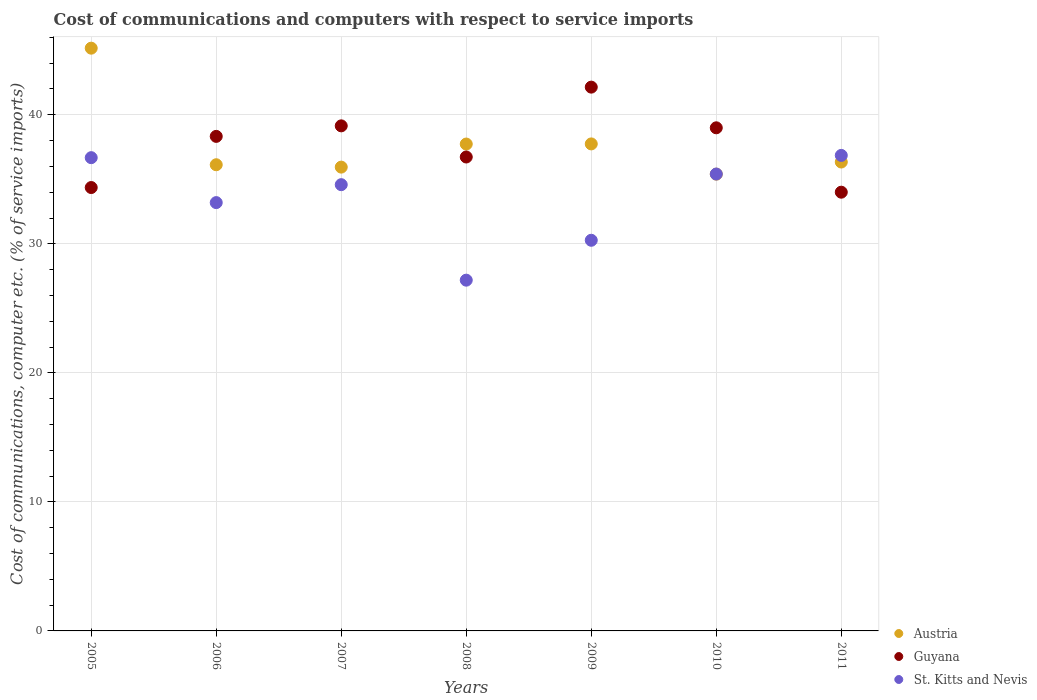How many different coloured dotlines are there?
Keep it short and to the point. 3. Is the number of dotlines equal to the number of legend labels?
Offer a terse response. Yes. What is the cost of communications and computers in Guyana in 2011?
Your response must be concise. 34. Across all years, what is the maximum cost of communications and computers in St. Kitts and Nevis?
Your answer should be very brief. 36.85. Across all years, what is the minimum cost of communications and computers in Austria?
Ensure brevity in your answer.  35.4. In which year was the cost of communications and computers in St. Kitts and Nevis maximum?
Provide a short and direct response. 2011. What is the total cost of communications and computers in St. Kitts and Nevis in the graph?
Ensure brevity in your answer.  234.17. What is the difference between the cost of communications and computers in St. Kitts and Nevis in 2008 and that in 2010?
Your response must be concise. -8.23. What is the difference between the cost of communications and computers in Guyana in 2009 and the cost of communications and computers in St. Kitts and Nevis in 2008?
Offer a very short reply. 14.96. What is the average cost of communications and computers in Austria per year?
Offer a terse response. 37.78. In the year 2008, what is the difference between the cost of communications and computers in Austria and cost of communications and computers in St. Kitts and Nevis?
Ensure brevity in your answer.  10.55. What is the ratio of the cost of communications and computers in Austria in 2009 to that in 2011?
Give a very brief answer. 1.04. Is the cost of communications and computers in Austria in 2008 less than that in 2011?
Offer a very short reply. No. Is the difference between the cost of communications and computers in Austria in 2006 and 2011 greater than the difference between the cost of communications and computers in St. Kitts and Nevis in 2006 and 2011?
Your answer should be compact. Yes. What is the difference between the highest and the second highest cost of communications and computers in Austria?
Offer a terse response. 7.42. What is the difference between the highest and the lowest cost of communications and computers in Guyana?
Ensure brevity in your answer.  8.14. Is the sum of the cost of communications and computers in Guyana in 2007 and 2009 greater than the maximum cost of communications and computers in Austria across all years?
Keep it short and to the point. Yes. Does the cost of communications and computers in Austria monotonically increase over the years?
Offer a very short reply. No. Is the cost of communications and computers in Austria strictly greater than the cost of communications and computers in Guyana over the years?
Keep it short and to the point. No. How many dotlines are there?
Your answer should be compact. 3. What is the difference between two consecutive major ticks on the Y-axis?
Make the answer very short. 10. Does the graph contain any zero values?
Your answer should be very brief. No. How many legend labels are there?
Offer a terse response. 3. What is the title of the graph?
Your response must be concise. Cost of communications and computers with respect to service imports. Does "Ghana" appear as one of the legend labels in the graph?
Keep it short and to the point. No. What is the label or title of the Y-axis?
Your answer should be very brief. Cost of communications, computer etc. (% of service imports). What is the Cost of communications, computer etc. (% of service imports) in Austria in 2005?
Make the answer very short. 45.16. What is the Cost of communications, computer etc. (% of service imports) of Guyana in 2005?
Your response must be concise. 34.36. What is the Cost of communications, computer etc. (% of service imports) of St. Kitts and Nevis in 2005?
Provide a short and direct response. 36.68. What is the Cost of communications, computer etc. (% of service imports) in Austria in 2006?
Make the answer very short. 36.13. What is the Cost of communications, computer etc. (% of service imports) in Guyana in 2006?
Offer a very short reply. 38.33. What is the Cost of communications, computer etc. (% of service imports) in St. Kitts and Nevis in 2006?
Keep it short and to the point. 33.19. What is the Cost of communications, computer etc. (% of service imports) of Austria in 2007?
Keep it short and to the point. 35.94. What is the Cost of communications, computer etc. (% of service imports) of Guyana in 2007?
Offer a very short reply. 39.14. What is the Cost of communications, computer etc. (% of service imports) of St. Kitts and Nevis in 2007?
Offer a terse response. 34.58. What is the Cost of communications, computer etc. (% of service imports) of Austria in 2008?
Give a very brief answer. 37.73. What is the Cost of communications, computer etc. (% of service imports) in Guyana in 2008?
Give a very brief answer. 36.73. What is the Cost of communications, computer etc. (% of service imports) in St. Kitts and Nevis in 2008?
Offer a very short reply. 27.18. What is the Cost of communications, computer etc. (% of service imports) of Austria in 2009?
Offer a very short reply. 37.74. What is the Cost of communications, computer etc. (% of service imports) in Guyana in 2009?
Ensure brevity in your answer.  42.14. What is the Cost of communications, computer etc. (% of service imports) of St. Kitts and Nevis in 2009?
Offer a terse response. 30.27. What is the Cost of communications, computer etc. (% of service imports) of Austria in 2010?
Provide a succinct answer. 35.4. What is the Cost of communications, computer etc. (% of service imports) of Guyana in 2010?
Give a very brief answer. 38.99. What is the Cost of communications, computer etc. (% of service imports) in St. Kitts and Nevis in 2010?
Offer a terse response. 35.41. What is the Cost of communications, computer etc. (% of service imports) of Austria in 2011?
Your answer should be very brief. 36.34. What is the Cost of communications, computer etc. (% of service imports) of Guyana in 2011?
Your answer should be very brief. 34. What is the Cost of communications, computer etc. (% of service imports) of St. Kitts and Nevis in 2011?
Your response must be concise. 36.85. Across all years, what is the maximum Cost of communications, computer etc. (% of service imports) of Austria?
Provide a short and direct response. 45.16. Across all years, what is the maximum Cost of communications, computer etc. (% of service imports) of Guyana?
Make the answer very short. 42.14. Across all years, what is the maximum Cost of communications, computer etc. (% of service imports) of St. Kitts and Nevis?
Your answer should be very brief. 36.85. Across all years, what is the minimum Cost of communications, computer etc. (% of service imports) in Austria?
Your response must be concise. 35.4. Across all years, what is the minimum Cost of communications, computer etc. (% of service imports) in Guyana?
Ensure brevity in your answer.  34. Across all years, what is the minimum Cost of communications, computer etc. (% of service imports) of St. Kitts and Nevis?
Offer a very short reply. 27.18. What is the total Cost of communications, computer etc. (% of service imports) in Austria in the graph?
Your response must be concise. 264.44. What is the total Cost of communications, computer etc. (% of service imports) of Guyana in the graph?
Make the answer very short. 263.69. What is the total Cost of communications, computer etc. (% of service imports) of St. Kitts and Nevis in the graph?
Your answer should be compact. 234.17. What is the difference between the Cost of communications, computer etc. (% of service imports) in Austria in 2005 and that in 2006?
Give a very brief answer. 9.03. What is the difference between the Cost of communications, computer etc. (% of service imports) of Guyana in 2005 and that in 2006?
Keep it short and to the point. -3.96. What is the difference between the Cost of communications, computer etc. (% of service imports) in St. Kitts and Nevis in 2005 and that in 2006?
Provide a short and direct response. 3.48. What is the difference between the Cost of communications, computer etc. (% of service imports) in Austria in 2005 and that in 2007?
Make the answer very short. 9.22. What is the difference between the Cost of communications, computer etc. (% of service imports) of Guyana in 2005 and that in 2007?
Provide a succinct answer. -4.78. What is the difference between the Cost of communications, computer etc. (% of service imports) of St. Kitts and Nevis in 2005 and that in 2007?
Your answer should be compact. 2.09. What is the difference between the Cost of communications, computer etc. (% of service imports) in Austria in 2005 and that in 2008?
Make the answer very short. 7.43. What is the difference between the Cost of communications, computer etc. (% of service imports) of Guyana in 2005 and that in 2008?
Your response must be concise. -2.37. What is the difference between the Cost of communications, computer etc. (% of service imports) in St. Kitts and Nevis in 2005 and that in 2008?
Your response must be concise. 9.49. What is the difference between the Cost of communications, computer etc. (% of service imports) in Austria in 2005 and that in 2009?
Keep it short and to the point. 7.42. What is the difference between the Cost of communications, computer etc. (% of service imports) in Guyana in 2005 and that in 2009?
Offer a terse response. -7.78. What is the difference between the Cost of communications, computer etc. (% of service imports) of St. Kitts and Nevis in 2005 and that in 2009?
Your answer should be very brief. 6.4. What is the difference between the Cost of communications, computer etc. (% of service imports) of Austria in 2005 and that in 2010?
Provide a succinct answer. 9.76. What is the difference between the Cost of communications, computer etc. (% of service imports) of Guyana in 2005 and that in 2010?
Offer a terse response. -4.63. What is the difference between the Cost of communications, computer etc. (% of service imports) of St. Kitts and Nevis in 2005 and that in 2010?
Give a very brief answer. 1.27. What is the difference between the Cost of communications, computer etc. (% of service imports) in Austria in 2005 and that in 2011?
Make the answer very short. 8.82. What is the difference between the Cost of communications, computer etc. (% of service imports) in Guyana in 2005 and that in 2011?
Offer a very short reply. 0.36. What is the difference between the Cost of communications, computer etc. (% of service imports) of St. Kitts and Nevis in 2005 and that in 2011?
Your response must be concise. -0.17. What is the difference between the Cost of communications, computer etc. (% of service imports) in Austria in 2006 and that in 2007?
Keep it short and to the point. 0.18. What is the difference between the Cost of communications, computer etc. (% of service imports) of Guyana in 2006 and that in 2007?
Ensure brevity in your answer.  -0.82. What is the difference between the Cost of communications, computer etc. (% of service imports) of St. Kitts and Nevis in 2006 and that in 2007?
Keep it short and to the point. -1.39. What is the difference between the Cost of communications, computer etc. (% of service imports) of Austria in 2006 and that in 2008?
Offer a terse response. -1.6. What is the difference between the Cost of communications, computer etc. (% of service imports) of Guyana in 2006 and that in 2008?
Make the answer very short. 1.6. What is the difference between the Cost of communications, computer etc. (% of service imports) in St. Kitts and Nevis in 2006 and that in 2008?
Your answer should be very brief. 6.01. What is the difference between the Cost of communications, computer etc. (% of service imports) of Austria in 2006 and that in 2009?
Your answer should be compact. -1.61. What is the difference between the Cost of communications, computer etc. (% of service imports) of Guyana in 2006 and that in 2009?
Your response must be concise. -3.82. What is the difference between the Cost of communications, computer etc. (% of service imports) of St. Kitts and Nevis in 2006 and that in 2009?
Your response must be concise. 2.92. What is the difference between the Cost of communications, computer etc. (% of service imports) in Austria in 2006 and that in 2010?
Provide a short and direct response. 0.73. What is the difference between the Cost of communications, computer etc. (% of service imports) in Guyana in 2006 and that in 2010?
Give a very brief answer. -0.66. What is the difference between the Cost of communications, computer etc. (% of service imports) in St. Kitts and Nevis in 2006 and that in 2010?
Provide a succinct answer. -2.21. What is the difference between the Cost of communications, computer etc. (% of service imports) of Austria in 2006 and that in 2011?
Offer a terse response. -0.21. What is the difference between the Cost of communications, computer etc. (% of service imports) of Guyana in 2006 and that in 2011?
Keep it short and to the point. 4.33. What is the difference between the Cost of communications, computer etc. (% of service imports) of St. Kitts and Nevis in 2006 and that in 2011?
Make the answer very short. -3.66. What is the difference between the Cost of communications, computer etc. (% of service imports) of Austria in 2007 and that in 2008?
Offer a very short reply. -1.79. What is the difference between the Cost of communications, computer etc. (% of service imports) in Guyana in 2007 and that in 2008?
Your response must be concise. 2.41. What is the difference between the Cost of communications, computer etc. (% of service imports) in St. Kitts and Nevis in 2007 and that in 2008?
Provide a short and direct response. 7.4. What is the difference between the Cost of communications, computer etc. (% of service imports) in Austria in 2007 and that in 2009?
Offer a very short reply. -1.8. What is the difference between the Cost of communications, computer etc. (% of service imports) of Guyana in 2007 and that in 2009?
Offer a terse response. -3. What is the difference between the Cost of communications, computer etc. (% of service imports) of St. Kitts and Nevis in 2007 and that in 2009?
Your response must be concise. 4.31. What is the difference between the Cost of communications, computer etc. (% of service imports) of Austria in 2007 and that in 2010?
Ensure brevity in your answer.  0.54. What is the difference between the Cost of communications, computer etc. (% of service imports) in Guyana in 2007 and that in 2010?
Offer a terse response. 0.15. What is the difference between the Cost of communications, computer etc. (% of service imports) in St. Kitts and Nevis in 2007 and that in 2010?
Offer a very short reply. -0.83. What is the difference between the Cost of communications, computer etc. (% of service imports) in Austria in 2007 and that in 2011?
Your answer should be compact. -0.39. What is the difference between the Cost of communications, computer etc. (% of service imports) in Guyana in 2007 and that in 2011?
Provide a succinct answer. 5.14. What is the difference between the Cost of communications, computer etc. (% of service imports) in St. Kitts and Nevis in 2007 and that in 2011?
Your answer should be very brief. -2.27. What is the difference between the Cost of communications, computer etc. (% of service imports) in Austria in 2008 and that in 2009?
Provide a succinct answer. -0.01. What is the difference between the Cost of communications, computer etc. (% of service imports) in Guyana in 2008 and that in 2009?
Offer a very short reply. -5.42. What is the difference between the Cost of communications, computer etc. (% of service imports) in St. Kitts and Nevis in 2008 and that in 2009?
Provide a succinct answer. -3.09. What is the difference between the Cost of communications, computer etc. (% of service imports) of Austria in 2008 and that in 2010?
Keep it short and to the point. 2.33. What is the difference between the Cost of communications, computer etc. (% of service imports) in Guyana in 2008 and that in 2010?
Your answer should be compact. -2.26. What is the difference between the Cost of communications, computer etc. (% of service imports) in St. Kitts and Nevis in 2008 and that in 2010?
Offer a terse response. -8.23. What is the difference between the Cost of communications, computer etc. (% of service imports) of Austria in 2008 and that in 2011?
Provide a succinct answer. 1.39. What is the difference between the Cost of communications, computer etc. (% of service imports) of Guyana in 2008 and that in 2011?
Make the answer very short. 2.73. What is the difference between the Cost of communications, computer etc. (% of service imports) of St. Kitts and Nevis in 2008 and that in 2011?
Your answer should be compact. -9.67. What is the difference between the Cost of communications, computer etc. (% of service imports) of Austria in 2009 and that in 2010?
Your response must be concise. 2.34. What is the difference between the Cost of communications, computer etc. (% of service imports) of Guyana in 2009 and that in 2010?
Make the answer very short. 3.15. What is the difference between the Cost of communications, computer etc. (% of service imports) of St. Kitts and Nevis in 2009 and that in 2010?
Ensure brevity in your answer.  -5.13. What is the difference between the Cost of communications, computer etc. (% of service imports) in Austria in 2009 and that in 2011?
Provide a succinct answer. 1.4. What is the difference between the Cost of communications, computer etc. (% of service imports) in Guyana in 2009 and that in 2011?
Your answer should be compact. 8.14. What is the difference between the Cost of communications, computer etc. (% of service imports) in St. Kitts and Nevis in 2009 and that in 2011?
Your response must be concise. -6.58. What is the difference between the Cost of communications, computer etc. (% of service imports) in Austria in 2010 and that in 2011?
Offer a terse response. -0.94. What is the difference between the Cost of communications, computer etc. (% of service imports) of Guyana in 2010 and that in 2011?
Provide a succinct answer. 4.99. What is the difference between the Cost of communications, computer etc. (% of service imports) in St. Kitts and Nevis in 2010 and that in 2011?
Offer a very short reply. -1.44. What is the difference between the Cost of communications, computer etc. (% of service imports) in Austria in 2005 and the Cost of communications, computer etc. (% of service imports) in Guyana in 2006?
Offer a very short reply. 6.84. What is the difference between the Cost of communications, computer etc. (% of service imports) of Austria in 2005 and the Cost of communications, computer etc. (% of service imports) of St. Kitts and Nevis in 2006?
Give a very brief answer. 11.97. What is the difference between the Cost of communications, computer etc. (% of service imports) in Guyana in 2005 and the Cost of communications, computer etc. (% of service imports) in St. Kitts and Nevis in 2006?
Offer a very short reply. 1.17. What is the difference between the Cost of communications, computer etc. (% of service imports) of Austria in 2005 and the Cost of communications, computer etc. (% of service imports) of Guyana in 2007?
Offer a very short reply. 6.02. What is the difference between the Cost of communications, computer etc. (% of service imports) in Austria in 2005 and the Cost of communications, computer etc. (% of service imports) in St. Kitts and Nevis in 2007?
Your answer should be compact. 10.58. What is the difference between the Cost of communications, computer etc. (% of service imports) in Guyana in 2005 and the Cost of communications, computer etc. (% of service imports) in St. Kitts and Nevis in 2007?
Ensure brevity in your answer.  -0.22. What is the difference between the Cost of communications, computer etc. (% of service imports) in Austria in 2005 and the Cost of communications, computer etc. (% of service imports) in Guyana in 2008?
Your response must be concise. 8.43. What is the difference between the Cost of communications, computer etc. (% of service imports) in Austria in 2005 and the Cost of communications, computer etc. (% of service imports) in St. Kitts and Nevis in 2008?
Your answer should be very brief. 17.98. What is the difference between the Cost of communications, computer etc. (% of service imports) in Guyana in 2005 and the Cost of communications, computer etc. (% of service imports) in St. Kitts and Nevis in 2008?
Keep it short and to the point. 7.18. What is the difference between the Cost of communications, computer etc. (% of service imports) in Austria in 2005 and the Cost of communications, computer etc. (% of service imports) in Guyana in 2009?
Provide a succinct answer. 3.02. What is the difference between the Cost of communications, computer etc. (% of service imports) of Austria in 2005 and the Cost of communications, computer etc. (% of service imports) of St. Kitts and Nevis in 2009?
Offer a terse response. 14.89. What is the difference between the Cost of communications, computer etc. (% of service imports) in Guyana in 2005 and the Cost of communications, computer etc. (% of service imports) in St. Kitts and Nevis in 2009?
Ensure brevity in your answer.  4.09. What is the difference between the Cost of communications, computer etc. (% of service imports) in Austria in 2005 and the Cost of communications, computer etc. (% of service imports) in Guyana in 2010?
Offer a very short reply. 6.17. What is the difference between the Cost of communications, computer etc. (% of service imports) in Austria in 2005 and the Cost of communications, computer etc. (% of service imports) in St. Kitts and Nevis in 2010?
Give a very brief answer. 9.75. What is the difference between the Cost of communications, computer etc. (% of service imports) of Guyana in 2005 and the Cost of communications, computer etc. (% of service imports) of St. Kitts and Nevis in 2010?
Your answer should be compact. -1.05. What is the difference between the Cost of communications, computer etc. (% of service imports) of Austria in 2005 and the Cost of communications, computer etc. (% of service imports) of Guyana in 2011?
Ensure brevity in your answer.  11.16. What is the difference between the Cost of communications, computer etc. (% of service imports) in Austria in 2005 and the Cost of communications, computer etc. (% of service imports) in St. Kitts and Nevis in 2011?
Offer a very short reply. 8.31. What is the difference between the Cost of communications, computer etc. (% of service imports) in Guyana in 2005 and the Cost of communications, computer etc. (% of service imports) in St. Kitts and Nevis in 2011?
Your answer should be compact. -2.49. What is the difference between the Cost of communications, computer etc. (% of service imports) of Austria in 2006 and the Cost of communications, computer etc. (% of service imports) of Guyana in 2007?
Ensure brevity in your answer.  -3.01. What is the difference between the Cost of communications, computer etc. (% of service imports) in Austria in 2006 and the Cost of communications, computer etc. (% of service imports) in St. Kitts and Nevis in 2007?
Your response must be concise. 1.54. What is the difference between the Cost of communications, computer etc. (% of service imports) of Guyana in 2006 and the Cost of communications, computer etc. (% of service imports) of St. Kitts and Nevis in 2007?
Provide a succinct answer. 3.74. What is the difference between the Cost of communications, computer etc. (% of service imports) of Austria in 2006 and the Cost of communications, computer etc. (% of service imports) of Guyana in 2008?
Keep it short and to the point. -0.6. What is the difference between the Cost of communications, computer etc. (% of service imports) in Austria in 2006 and the Cost of communications, computer etc. (% of service imports) in St. Kitts and Nevis in 2008?
Ensure brevity in your answer.  8.94. What is the difference between the Cost of communications, computer etc. (% of service imports) of Guyana in 2006 and the Cost of communications, computer etc. (% of service imports) of St. Kitts and Nevis in 2008?
Offer a very short reply. 11.14. What is the difference between the Cost of communications, computer etc. (% of service imports) in Austria in 2006 and the Cost of communications, computer etc. (% of service imports) in Guyana in 2009?
Your answer should be compact. -6.01. What is the difference between the Cost of communications, computer etc. (% of service imports) in Austria in 2006 and the Cost of communications, computer etc. (% of service imports) in St. Kitts and Nevis in 2009?
Keep it short and to the point. 5.85. What is the difference between the Cost of communications, computer etc. (% of service imports) in Guyana in 2006 and the Cost of communications, computer etc. (% of service imports) in St. Kitts and Nevis in 2009?
Provide a short and direct response. 8.05. What is the difference between the Cost of communications, computer etc. (% of service imports) in Austria in 2006 and the Cost of communications, computer etc. (% of service imports) in Guyana in 2010?
Provide a succinct answer. -2.86. What is the difference between the Cost of communications, computer etc. (% of service imports) in Austria in 2006 and the Cost of communications, computer etc. (% of service imports) in St. Kitts and Nevis in 2010?
Give a very brief answer. 0.72. What is the difference between the Cost of communications, computer etc. (% of service imports) in Guyana in 2006 and the Cost of communications, computer etc. (% of service imports) in St. Kitts and Nevis in 2010?
Your answer should be compact. 2.92. What is the difference between the Cost of communications, computer etc. (% of service imports) in Austria in 2006 and the Cost of communications, computer etc. (% of service imports) in Guyana in 2011?
Offer a terse response. 2.13. What is the difference between the Cost of communications, computer etc. (% of service imports) of Austria in 2006 and the Cost of communications, computer etc. (% of service imports) of St. Kitts and Nevis in 2011?
Provide a short and direct response. -0.72. What is the difference between the Cost of communications, computer etc. (% of service imports) in Guyana in 2006 and the Cost of communications, computer etc. (% of service imports) in St. Kitts and Nevis in 2011?
Ensure brevity in your answer.  1.48. What is the difference between the Cost of communications, computer etc. (% of service imports) of Austria in 2007 and the Cost of communications, computer etc. (% of service imports) of Guyana in 2008?
Give a very brief answer. -0.78. What is the difference between the Cost of communications, computer etc. (% of service imports) in Austria in 2007 and the Cost of communications, computer etc. (% of service imports) in St. Kitts and Nevis in 2008?
Provide a succinct answer. 8.76. What is the difference between the Cost of communications, computer etc. (% of service imports) in Guyana in 2007 and the Cost of communications, computer etc. (% of service imports) in St. Kitts and Nevis in 2008?
Keep it short and to the point. 11.96. What is the difference between the Cost of communications, computer etc. (% of service imports) in Austria in 2007 and the Cost of communications, computer etc. (% of service imports) in Guyana in 2009?
Provide a succinct answer. -6.2. What is the difference between the Cost of communications, computer etc. (% of service imports) in Austria in 2007 and the Cost of communications, computer etc. (% of service imports) in St. Kitts and Nevis in 2009?
Provide a short and direct response. 5.67. What is the difference between the Cost of communications, computer etc. (% of service imports) in Guyana in 2007 and the Cost of communications, computer etc. (% of service imports) in St. Kitts and Nevis in 2009?
Ensure brevity in your answer.  8.87. What is the difference between the Cost of communications, computer etc. (% of service imports) in Austria in 2007 and the Cost of communications, computer etc. (% of service imports) in Guyana in 2010?
Give a very brief answer. -3.05. What is the difference between the Cost of communications, computer etc. (% of service imports) in Austria in 2007 and the Cost of communications, computer etc. (% of service imports) in St. Kitts and Nevis in 2010?
Give a very brief answer. 0.54. What is the difference between the Cost of communications, computer etc. (% of service imports) in Guyana in 2007 and the Cost of communications, computer etc. (% of service imports) in St. Kitts and Nevis in 2010?
Make the answer very short. 3.73. What is the difference between the Cost of communications, computer etc. (% of service imports) of Austria in 2007 and the Cost of communications, computer etc. (% of service imports) of Guyana in 2011?
Your answer should be compact. 1.94. What is the difference between the Cost of communications, computer etc. (% of service imports) in Austria in 2007 and the Cost of communications, computer etc. (% of service imports) in St. Kitts and Nevis in 2011?
Your response must be concise. -0.91. What is the difference between the Cost of communications, computer etc. (% of service imports) in Guyana in 2007 and the Cost of communications, computer etc. (% of service imports) in St. Kitts and Nevis in 2011?
Your answer should be very brief. 2.29. What is the difference between the Cost of communications, computer etc. (% of service imports) of Austria in 2008 and the Cost of communications, computer etc. (% of service imports) of Guyana in 2009?
Your response must be concise. -4.41. What is the difference between the Cost of communications, computer etc. (% of service imports) in Austria in 2008 and the Cost of communications, computer etc. (% of service imports) in St. Kitts and Nevis in 2009?
Keep it short and to the point. 7.46. What is the difference between the Cost of communications, computer etc. (% of service imports) in Guyana in 2008 and the Cost of communications, computer etc. (% of service imports) in St. Kitts and Nevis in 2009?
Make the answer very short. 6.45. What is the difference between the Cost of communications, computer etc. (% of service imports) in Austria in 2008 and the Cost of communications, computer etc. (% of service imports) in Guyana in 2010?
Keep it short and to the point. -1.26. What is the difference between the Cost of communications, computer etc. (% of service imports) of Austria in 2008 and the Cost of communications, computer etc. (% of service imports) of St. Kitts and Nevis in 2010?
Offer a very short reply. 2.32. What is the difference between the Cost of communications, computer etc. (% of service imports) of Guyana in 2008 and the Cost of communications, computer etc. (% of service imports) of St. Kitts and Nevis in 2010?
Provide a succinct answer. 1.32. What is the difference between the Cost of communications, computer etc. (% of service imports) in Austria in 2008 and the Cost of communications, computer etc. (% of service imports) in Guyana in 2011?
Your answer should be compact. 3.73. What is the difference between the Cost of communications, computer etc. (% of service imports) of Austria in 2008 and the Cost of communications, computer etc. (% of service imports) of St. Kitts and Nevis in 2011?
Your response must be concise. 0.88. What is the difference between the Cost of communications, computer etc. (% of service imports) in Guyana in 2008 and the Cost of communications, computer etc. (% of service imports) in St. Kitts and Nevis in 2011?
Ensure brevity in your answer.  -0.12. What is the difference between the Cost of communications, computer etc. (% of service imports) in Austria in 2009 and the Cost of communications, computer etc. (% of service imports) in Guyana in 2010?
Give a very brief answer. -1.25. What is the difference between the Cost of communications, computer etc. (% of service imports) in Austria in 2009 and the Cost of communications, computer etc. (% of service imports) in St. Kitts and Nevis in 2010?
Offer a very short reply. 2.33. What is the difference between the Cost of communications, computer etc. (% of service imports) of Guyana in 2009 and the Cost of communications, computer etc. (% of service imports) of St. Kitts and Nevis in 2010?
Provide a succinct answer. 6.73. What is the difference between the Cost of communications, computer etc. (% of service imports) in Austria in 2009 and the Cost of communications, computer etc. (% of service imports) in Guyana in 2011?
Offer a very short reply. 3.74. What is the difference between the Cost of communications, computer etc. (% of service imports) of Austria in 2009 and the Cost of communications, computer etc. (% of service imports) of St. Kitts and Nevis in 2011?
Your answer should be very brief. 0.89. What is the difference between the Cost of communications, computer etc. (% of service imports) in Guyana in 2009 and the Cost of communications, computer etc. (% of service imports) in St. Kitts and Nevis in 2011?
Provide a succinct answer. 5.29. What is the difference between the Cost of communications, computer etc. (% of service imports) in Austria in 2010 and the Cost of communications, computer etc. (% of service imports) in Guyana in 2011?
Make the answer very short. 1.4. What is the difference between the Cost of communications, computer etc. (% of service imports) in Austria in 2010 and the Cost of communications, computer etc. (% of service imports) in St. Kitts and Nevis in 2011?
Ensure brevity in your answer.  -1.45. What is the difference between the Cost of communications, computer etc. (% of service imports) of Guyana in 2010 and the Cost of communications, computer etc. (% of service imports) of St. Kitts and Nevis in 2011?
Your response must be concise. 2.14. What is the average Cost of communications, computer etc. (% of service imports) in Austria per year?
Your answer should be very brief. 37.78. What is the average Cost of communications, computer etc. (% of service imports) in Guyana per year?
Your answer should be very brief. 37.67. What is the average Cost of communications, computer etc. (% of service imports) in St. Kitts and Nevis per year?
Provide a short and direct response. 33.45. In the year 2005, what is the difference between the Cost of communications, computer etc. (% of service imports) in Austria and Cost of communications, computer etc. (% of service imports) in Guyana?
Ensure brevity in your answer.  10.8. In the year 2005, what is the difference between the Cost of communications, computer etc. (% of service imports) in Austria and Cost of communications, computer etc. (% of service imports) in St. Kitts and Nevis?
Provide a succinct answer. 8.49. In the year 2005, what is the difference between the Cost of communications, computer etc. (% of service imports) of Guyana and Cost of communications, computer etc. (% of service imports) of St. Kitts and Nevis?
Your answer should be compact. -2.31. In the year 2006, what is the difference between the Cost of communications, computer etc. (% of service imports) in Austria and Cost of communications, computer etc. (% of service imports) in Guyana?
Your answer should be very brief. -2.2. In the year 2006, what is the difference between the Cost of communications, computer etc. (% of service imports) of Austria and Cost of communications, computer etc. (% of service imports) of St. Kitts and Nevis?
Provide a short and direct response. 2.93. In the year 2006, what is the difference between the Cost of communications, computer etc. (% of service imports) of Guyana and Cost of communications, computer etc. (% of service imports) of St. Kitts and Nevis?
Offer a terse response. 5.13. In the year 2007, what is the difference between the Cost of communications, computer etc. (% of service imports) in Austria and Cost of communications, computer etc. (% of service imports) in Guyana?
Offer a terse response. -3.2. In the year 2007, what is the difference between the Cost of communications, computer etc. (% of service imports) of Austria and Cost of communications, computer etc. (% of service imports) of St. Kitts and Nevis?
Ensure brevity in your answer.  1.36. In the year 2007, what is the difference between the Cost of communications, computer etc. (% of service imports) in Guyana and Cost of communications, computer etc. (% of service imports) in St. Kitts and Nevis?
Provide a short and direct response. 4.56. In the year 2008, what is the difference between the Cost of communications, computer etc. (% of service imports) of Austria and Cost of communications, computer etc. (% of service imports) of Guyana?
Your response must be concise. 1. In the year 2008, what is the difference between the Cost of communications, computer etc. (% of service imports) of Austria and Cost of communications, computer etc. (% of service imports) of St. Kitts and Nevis?
Keep it short and to the point. 10.55. In the year 2008, what is the difference between the Cost of communications, computer etc. (% of service imports) of Guyana and Cost of communications, computer etc. (% of service imports) of St. Kitts and Nevis?
Give a very brief answer. 9.54. In the year 2009, what is the difference between the Cost of communications, computer etc. (% of service imports) of Austria and Cost of communications, computer etc. (% of service imports) of Guyana?
Your answer should be very brief. -4.4. In the year 2009, what is the difference between the Cost of communications, computer etc. (% of service imports) of Austria and Cost of communications, computer etc. (% of service imports) of St. Kitts and Nevis?
Give a very brief answer. 7.47. In the year 2009, what is the difference between the Cost of communications, computer etc. (% of service imports) in Guyana and Cost of communications, computer etc. (% of service imports) in St. Kitts and Nevis?
Offer a very short reply. 11.87. In the year 2010, what is the difference between the Cost of communications, computer etc. (% of service imports) of Austria and Cost of communications, computer etc. (% of service imports) of Guyana?
Provide a short and direct response. -3.59. In the year 2010, what is the difference between the Cost of communications, computer etc. (% of service imports) of Austria and Cost of communications, computer etc. (% of service imports) of St. Kitts and Nevis?
Your answer should be very brief. -0.01. In the year 2010, what is the difference between the Cost of communications, computer etc. (% of service imports) of Guyana and Cost of communications, computer etc. (% of service imports) of St. Kitts and Nevis?
Offer a terse response. 3.58. In the year 2011, what is the difference between the Cost of communications, computer etc. (% of service imports) of Austria and Cost of communications, computer etc. (% of service imports) of Guyana?
Keep it short and to the point. 2.34. In the year 2011, what is the difference between the Cost of communications, computer etc. (% of service imports) in Austria and Cost of communications, computer etc. (% of service imports) in St. Kitts and Nevis?
Provide a succinct answer. -0.51. In the year 2011, what is the difference between the Cost of communications, computer etc. (% of service imports) of Guyana and Cost of communications, computer etc. (% of service imports) of St. Kitts and Nevis?
Provide a short and direct response. -2.85. What is the ratio of the Cost of communications, computer etc. (% of service imports) in Austria in 2005 to that in 2006?
Ensure brevity in your answer.  1.25. What is the ratio of the Cost of communications, computer etc. (% of service imports) in Guyana in 2005 to that in 2006?
Offer a terse response. 0.9. What is the ratio of the Cost of communications, computer etc. (% of service imports) in St. Kitts and Nevis in 2005 to that in 2006?
Give a very brief answer. 1.1. What is the ratio of the Cost of communications, computer etc. (% of service imports) of Austria in 2005 to that in 2007?
Make the answer very short. 1.26. What is the ratio of the Cost of communications, computer etc. (% of service imports) of Guyana in 2005 to that in 2007?
Your answer should be very brief. 0.88. What is the ratio of the Cost of communications, computer etc. (% of service imports) in St. Kitts and Nevis in 2005 to that in 2007?
Give a very brief answer. 1.06. What is the ratio of the Cost of communications, computer etc. (% of service imports) in Austria in 2005 to that in 2008?
Your response must be concise. 1.2. What is the ratio of the Cost of communications, computer etc. (% of service imports) of Guyana in 2005 to that in 2008?
Keep it short and to the point. 0.94. What is the ratio of the Cost of communications, computer etc. (% of service imports) of St. Kitts and Nevis in 2005 to that in 2008?
Your answer should be compact. 1.35. What is the ratio of the Cost of communications, computer etc. (% of service imports) of Austria in 2005 to that in 2009?
Provide a short and direct response. 1.2. What is the ratio of the Cost of communications, computer etc. (% of service imports) of Guyana in 2005 to that in 2009?
Your response must be concise. 0.82. What is the ratio of the Cost of communications, computer etc. (% of service imports) in St. Kitts and Nevis in 2005 to that in 2009?
Keep it short and to the point. 1.21. What is the ratio of the Cost of communications, computer etc. (% of service imports) in Austria in 2005 to that in 2010?
Your answer should be very brief. 1.28. What is the ratio of the Cost of communications, computer etc. (% of service imports) in Guyana in 2005 to that in 2010?
Give a very brief answer. 0.88. What is the ratio of the Cost of communications, computer etc. (% of service imports) in St. Kitts and Nevis in 2005 to that in 2010?
Ensure brevity in your answer.  1.04. What is the ratio of the Cost of communications, computer etc. (% of service imports) of Austria in 2005 to that in 2011?
Offer a terse response. 1.24. What is the ratio of the Cost of communications, computer etc. (% of service imports) of Guyana in 2005 to that in 2011?
Provide a short and direct response. 1.01. What is the ratio of the Cost of communications, computer etc. (% of service imports) of St. Kitts and Nevis in 2005 to that in 2011?
Give a very brief answer. 1. What is the ratio of the Cost of communications, computer etc. (% of service imports) in Austria in 2006 to that in 2007?
Make the answer very short. 1.01. What is the ratio of the Cost of communications, computer etc. (% of service imports) of Guyana in 2006 to that in 2007?
Your answer should be compact. 0.98. What is the ratio of the Cost of communications, computer etc. (% of service imports) in St. Kitts and Nevis in 2006 to that in 2007?
Ensure brevity in your answer.  0.96. What is the ratio of the Cost of communications, computer etc. (% of service imports) in Austria in 2006 to that in 2008?
Your response must be concise. 0.96. What is the ratio of the Cost of communications, computer etc. (% of service imports) in Guyana in 2006 to that in 2008?
Make the answer very short. 1.04. What is the ratio of the Cost of communications, computer etc. (% of service imports) in St. Kitts and Nevis in 2006 to that in 2008?
Ensure brevity in your answer.  1.22. What is the ratio of the Cost of communications, computer etc. (% of service imports) of Austria in 2006 to that in 2009?
Provide a short and direct response. 0.96. What is the ratio of the Cost of communications, computer etc. (% of service imports) in Guyana in 2006 to that in 2009?
Provide a succinct answer. 0.91. What is the ratio of the Cost of communications, computer etc. (% of service imports) of St. Kitts and Nevis in 2006 to that in 2009?
Make the answer very short. 1.1. What is the ratio of the Cost of communications, computer etc. (% of service imports) of Austria in 2006 to that in 2010?
Your answer should be very brief. 1.02. What is the ratio of the Cost of communications, computer etc. (% of service imports) of Guyana in 2006 to that in 2010?
Offer a terse response. 0.98. What is the ratio of the Cost of communications, computer etc. (% of service imports) in St. Kitts and Nevis in 2006 to that in 2010?
Provide a succinct answer. 0.94. What is the ratio of the Cost of communications, computer etc. (% of service imports) of Austria in 2006 to that in 2011?
Offer a very short reply. 0.99. What is the ratio of the Cost of communications, computer etc. (% of service imports) in Guyana in 2006 to that in 2011?
Keep it short and to the point. 1.13. What is the ratio of the Cost of communications, computer etc. (% of service imports) of St. Kitts and Nevis in 2006 to that in 2011?
Offer a terse response. 0.9. What is the ratio of the Cost of communications, computer etc. (% of service imports) of Austria in 2007 to that in 2008?
Give a very brief answer. 0.95. What is the ratio of the Cost of communications, computer etc. (% of service imports) in Guyana in 2007 to that in 2008?
Offer a very short reply. 1.07. What is the ratio of the Cost of communications, computer etc. (% of service imports) of St. Kitts and Nevis in 2007 to that in 2008?
Make the answer very short. 1.27. What is the ratio of the Cost of communications, computer etc. (% of service imports) of Guyana in 2007 to that in 2009?
Provide a succinct answer. 0.93. What is the ratio of the Cost of communications, computer etc. (% of service imports) of St. Kitts and Nevis in 2007 to that in 2009?
Your answer should be very brief. 1.14. What is the ratio of the Cost of communications, computer etc. (% of service imports) in Austria in 2007 to that in 2010?
Provide a short and direct response. 1.02. What is the ratio of the Cost of communications, computer etc. (% of service imports) in Guyana in 2007 to that in 2010?
Make the answer very short. 1. What is the ratio of the Cost of communications, computer etc. (% of service imports) of St. Kitts and Nevis in 2007 to that in 2010?
Make the answer very short. 0.98. What is the ratio of the Cost of communications, computer etc. (% of service imports) in Austria in 2007 to that in 2011?
Offer a terse response. 0.99. What is the ratio of the Cost of communications, computer etc. (% of service imports) of Guyana in 2007 to that in 2011?
Make the answer very short. 1.15. What is the ratio of the Cost of communications, computer etc. (% of service imports) of St. Kitts and Nevis in 2007 to that in 2011?
Your response must be concise. 0.94. What is the ratio of the Cost of communications, computer etc. (% of service imports) in Guyana in 2008 to that in 2009?
Give a very brief answer. 0.87. What is the ratio of the Cost of communications, computer etc. (% of service imports) in St. Kitts and Nevis in 2008 to that in 2009?
Offer a very short reply. 0.9. What is the ratio of the Cost of communications, computer etc. (% of service imports) of Austria in 2008 to that in 2010?
Keep it short and to the point. 1.07. What is the ratio of the Cost of communications, computer etc. (% of service imports) in Guyana in 2008 to that in 2010?
Provide a short and direct response. 0.94. What is the ratio of the Cost of communications, computer etc. (% of service imports) in St. Kitts and Nevis in 2008 to that in 2010?
Provide a succinct answer. 0.77. What is the ratio of the Cost of communications, computer etc. (% of service imports) in Austria in 2008 to that in 2011?
Ensure brevity in your answer.  1.04. What is the ratio of the Cost of communications, computer etc. (% of service imports) of Guyana in 2008 to that in 2011?
Offer a very short reply. 1.08. What is the ratio of the Cost of communications, computer etc. (% of service imports) in St. Kitts and Nevis in 2008 to that in 2011?
Offer a terse response. 0.74. What is the ratio of the Cost of communications, computer etc. (% of service imports) of Austria in 2009 to that in 2010?
Ensure brevity in your answer.  1.07. What is the ratio of the Cost of communications, computer etc. (% of service imports) in Guyana in 2009 to that in 2010?
Keep it short and to the point. 1.08. What is the ratio of the Cost of communications, computer etc. (% of service imports) in St. Kitts and Nevis in 2009 to that in 2010?
Give a very brief answer. 0.85. What is the ratio of the Cost of communications, computer etc. (% of service imports) of Austria in 2009 to that in 2011?
Give a very brief answer. 1.04. What is the ratio of the Cost of communications, computer etc. (% of service imports) of Guyana in 2009 to that in 2011?
Ensure brevity in your answer.  1.24. What is the ratio of the Cost of communications, computer etc. (% of service imports) of St. Kitts and Nevis in 2009 to that in 2011?
Offer a very short reply. 0.82. What is the ratio of the Cost of communications, computer etc. (% of service imports) of Austria in 2010 to that in 2011?
Offer a very short reply. 0.97. What is the ratio of the Cost of communications, computer etc. (% of service imports) of Guyana in 2010 to that in 2011?
Provide a succinct answer. 1.15. What is the ratio of the Cost of communications, computer etc. (% of service imports) in St. Kitts and Nevis in 2010 to that in 2011?
Your response must be concise. 0.96. What is the difference between the highest and the second highest Cost of communications, computer etc. (% of service imports) of Austria?
Your response must be concise. 7.42. What is the difference between the highest and the second highest Cost of communications, computer etc. (% of service imports) of Guyana?
Offer a terse response. 3. What is the difference between the highest and the second highest Cost of communications, computer etc. (% of service imports) of St. Kitts and Nevis?
Ensure brevity in your answer.  0.17. What is the difference between the highest and the lowest Cost of communications, computer etc. (% of service imports) in Austria?
Offer a terse response. 9.76. What is the difference between the highest and the lowest Cost of communications, computer etc. (% of service imports) in Guyana?
Your answer should be compact. 8.14. What is the difference between the highest and the lowest Cost of communications, computer etc. (% of service imports) in St. Kitts and Nevis?
Ensure brevity in your answer.  9.67. 